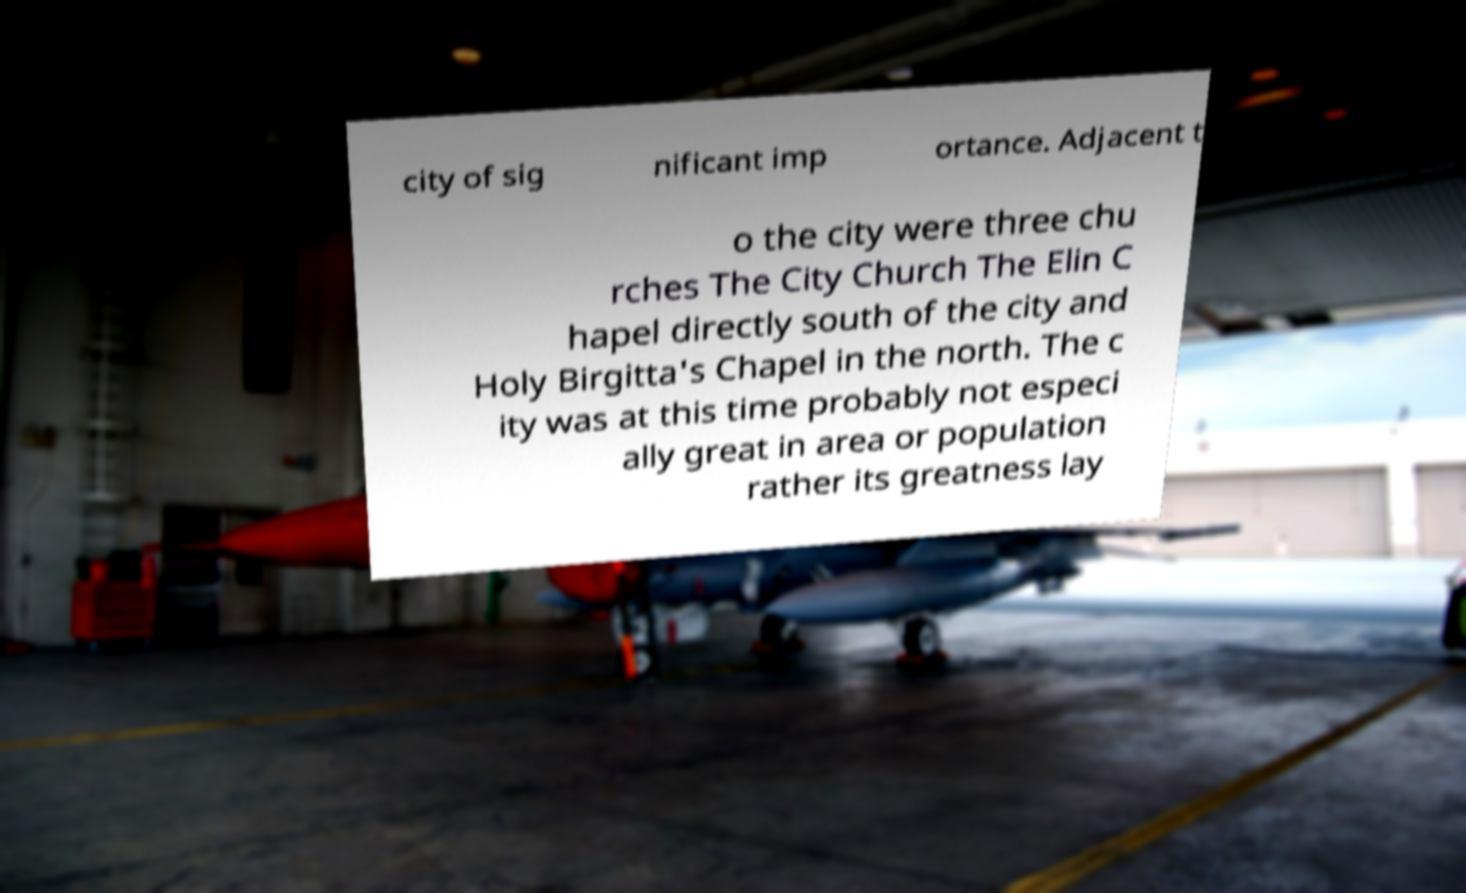There's text embedded in this image that I need extracted. Can you transcribe it verbatim? city of sig nificant imp ortance. Adjacent t o the city were three chu rches The City Church The Elin C hapel directly south of the city and Holy Birgitta's Chapel in the north. The c ity was at this time probably not especi ally great in area or population rather its greatness lay 